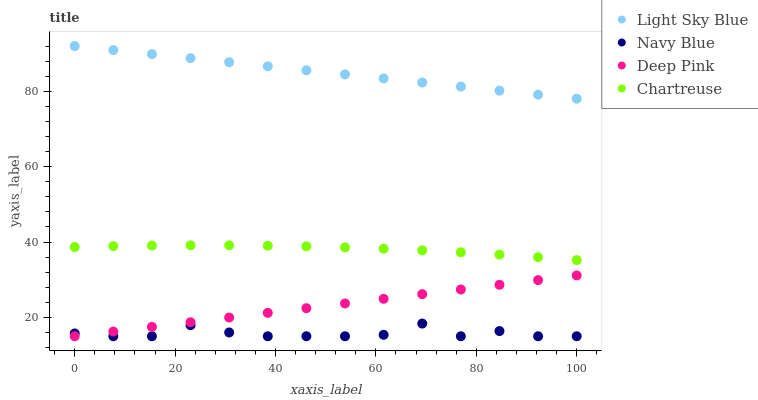Does Navy Blue have the minimum area under the curve?
Answer yes or no. Yes. Does Light Sky Blue have the maximum area under the curve?
Answer yes or no. Yes. Does Chartreuse have the minimum area under the curve?
Answer yes or no. No. Does Chartreuse have the maximum area under the curve?
Answer yes or no. No. Is Deep Pink the smoothest?
Answer yes or no. Yes. Is Navy Blue the roughest?
Answer yes or no. Yes. Is Chartreuse the smoothest?
Answer yes or no. No. Is Chartreuse the roughest?
Answer yes or no. No. Does Navy Blue have the lowest value?
Answer yes or no. Yes. Does Chartreuse have the lowest value?
Answer yes or no. No. Does Light Sky Blue have the highest value?
Answer yes or no. Yes. Does Chartreuse have the highest value?
Answer yes or no. No. Is Deep Pink less than Chartreuse?
Answer yes or no. Yes. Is Chartreuse greater than Navy Blue?
Answer yes or no. Yes. Does Navy Blue intersect Deep Pink?
Answer yes or no. Yes. Is Navy Blue less than Deep Pink?
Answer yes or no. No. Is Navy Blue greater than Deep Pink?
Answer yes or no. No. Does Deep Pink intersect Chartreuse?
Answer yes or no. No. 